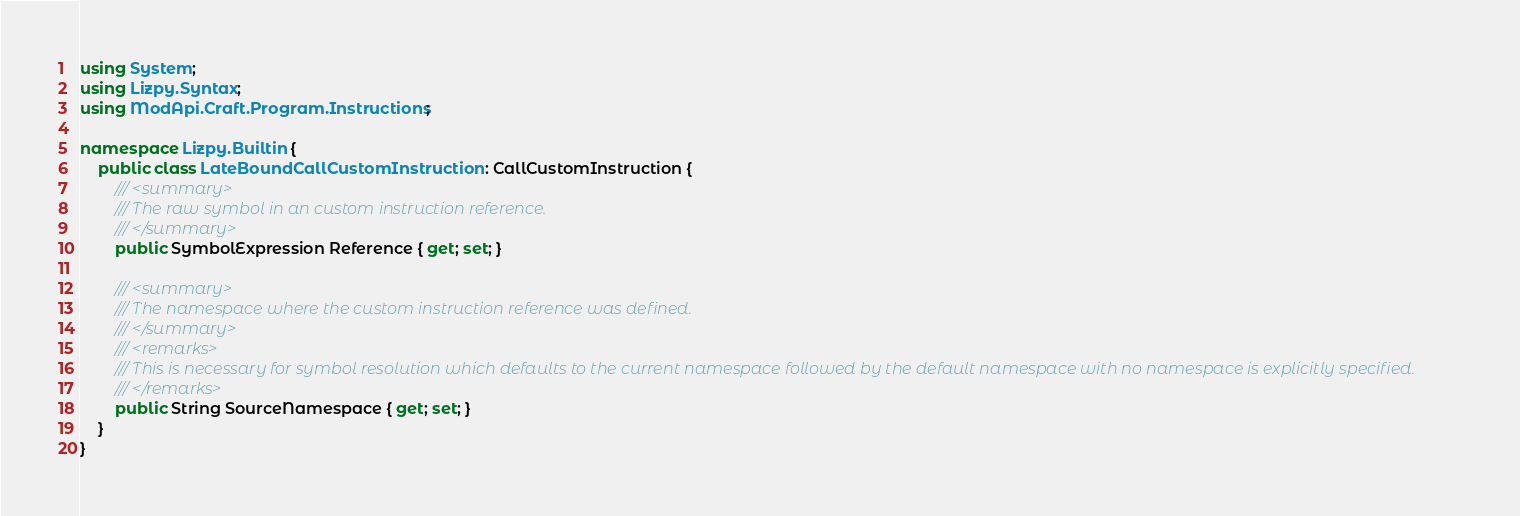Convert code to text. <code><loc_0><loc_0><loc_500><loc_500><_C#_>using System;
using Lizpy.Syntax;
using ModApi.Craft.Program.Instructions;

namespace Lizpy.Builtin {
    public class LateBoundCallCustomInstruction : CallCustomInstruction {
        /// <summary>
        /// The raw symbol in an custom instruction reference.
        /// </summary>
        public SymbolExpression Reference { get; set; }

        /// <summary>
        /// The namespace where the custom instruction reference was defined.
        /// </summary>
        /// <remarks>
        /// This is necessary for symbol resolution which defaults to the current namespace followed by the default namespace with no namespace is explicitly specified.
        /// </remarks>
        public String SourceNamespace { get; set; }
    }
}
</code> 